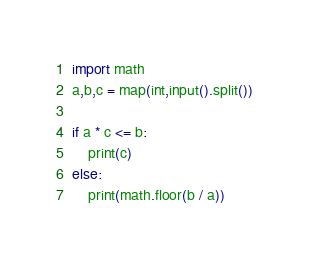<code> <loc_0><loc_0><loc_500><loc_500><_Python_>import math
a,b,c = map(int,input().split())

if a * c <= b:
    print(c)
else:
    print(math.floor(b / a))</code> 